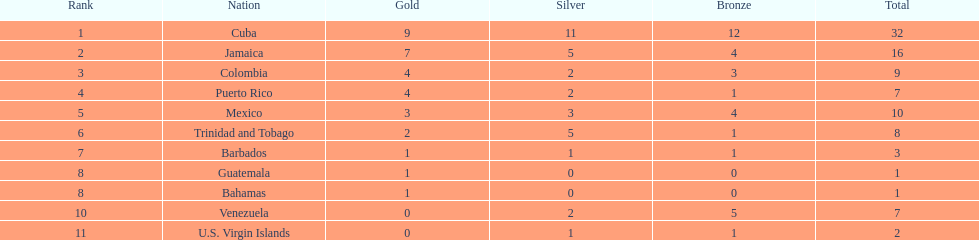Which team managed to achieve four gold and one bronze medals? Puerto Rico. 